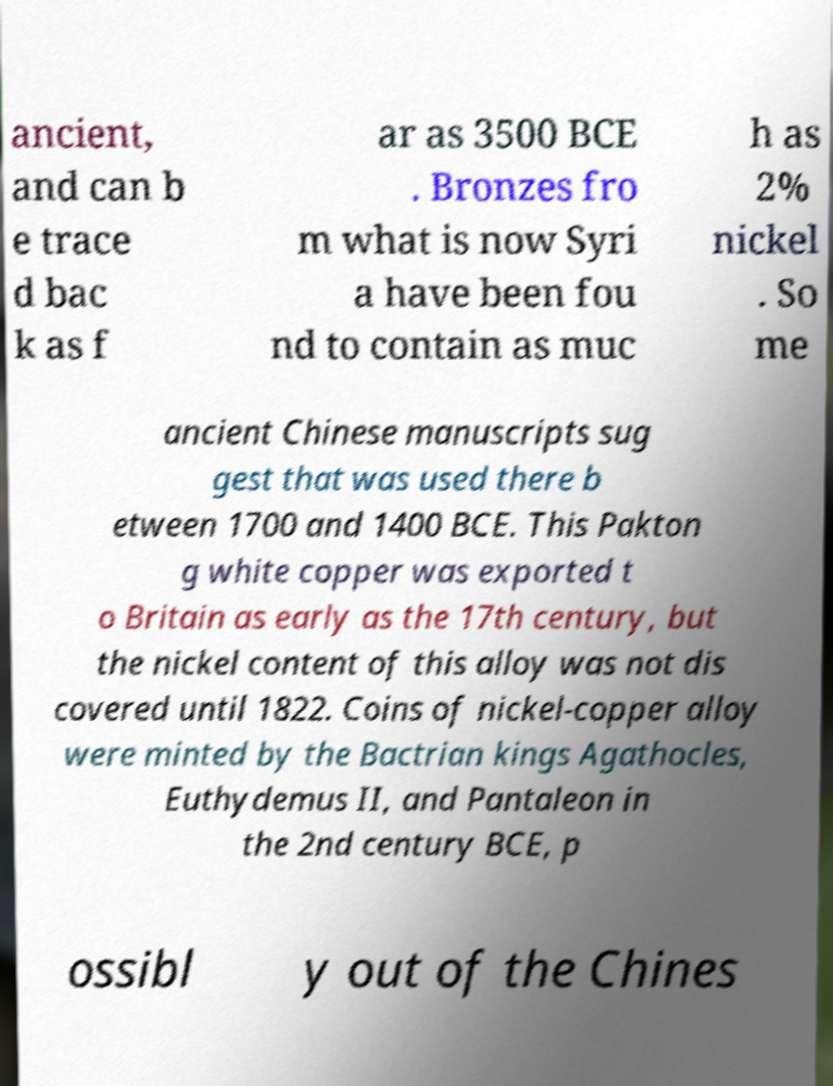Could you assist in decoding the text presented in this image and type it out clearly? ancient, and can b e trace d bac k as f ar as 3500 BCE . Bronzes fro m what is now Syri a have been fou nd to contain as muc h as 2% nickel . So me ancient Chinese manuscripts sug gest that was used there b etween 1700 and 1400 BCE. This Pakton g white copper was exported t o Britain as early as the 17th century, but the nickel content of this alloy was not dis covered until 1822. Coins of nickel-copper alloy were minted by the Bactrian kings Agathocles, Euthydemus II, and Pantaleon in the 2nd century BCE, p ossibl y out of the Chines 